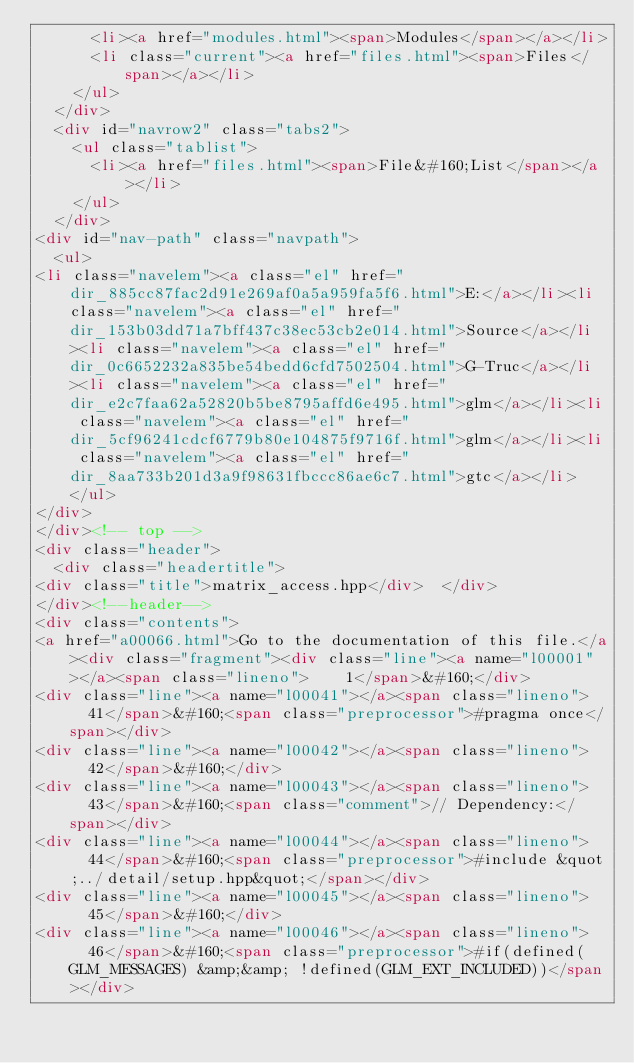<code> <loc_0><loc_0><loc_500><loc_500><_HTML_>      <li><a href="modules.html"><span>Modules</span></a></li>
      <li class="current"><a href="files.html"><span>Files</span></a></li>
    </ul>
  </div>
  <div id="navrow2" class="tabs2">
    <ul class="tablist">
      <li><a href="files.html"><span>File&#160;List</span></a></li>
    </ul>
  </div>
<div id="nav-path" class="navpath">
  <ul>
<li class="navelem"><a class="el" href="dir_885cc87fac2d91e269af0a5a959fa5f6.html">E:</a></li><li class="navelem"><a class="el" href="dir_153b03dd71a7bff437c38ec53cb2e014.html">Source</a></li><li class="navelem"><a class="el" href="dir_0c6652232a835be54bedd6cfd7502504.html">G-Truc</a></li><li class="navelem"><a class="el" href="dir_e2c7faa62a52820b5be8795affd6e495.html">glm</a></li><li class="navelem"><a class="el" href="dir_5cf96241cdcf6779b80e104875f9716f.html">glm</a></li><li class="navelem"><a class="el" href="dir_8aa733b201d3a9f98631fbccc86ae6c7.html">gtc</a></li>  </ul>
</div>
</div><!-- top -->
<div class="header">
  <div class="headertitle">
<div class="title">matrix_access.hpp</div>  </div>
</div><!--header-->
<div class="contents">
<a href="a00066.html">Go to the documentation of this file.</a><div class="fragment"><div class="line"><a name="l00001"></a><span class="lineno">    1</span>&#160;</div>
<div class="line"><a name="l00041"></a><span class="lineno">   41</span>&#160;<span class="preprocessor">#pragma once</span></div>
<div class="line"><a name="l00042"></a><span class="lineno">   42</span>&#160;</div>
<div class="line"><a name="l00043"></a><span class="lineno">   43</span>&#160;<span class="comment">// Dependency:</span></div>
<div class="line"><a name="l00044"></a><span class="lineno">   44</span>&#160;<span class="preprocessor">#include &quot;../detail/setup.hpp&quot;</span></div>
<div class="line"><a name="l00045"></a><span class="lineno">   45</span>&#160;</div>
<div class="line"><a name="l00046"></a><span class="lineno">   46</span>&#160;<span class="preprocessor">#if(defined(GLM_MESSAGES) &amp;&amp; !defined(GLM_EXT_INCLUDED))</span></div></code> 